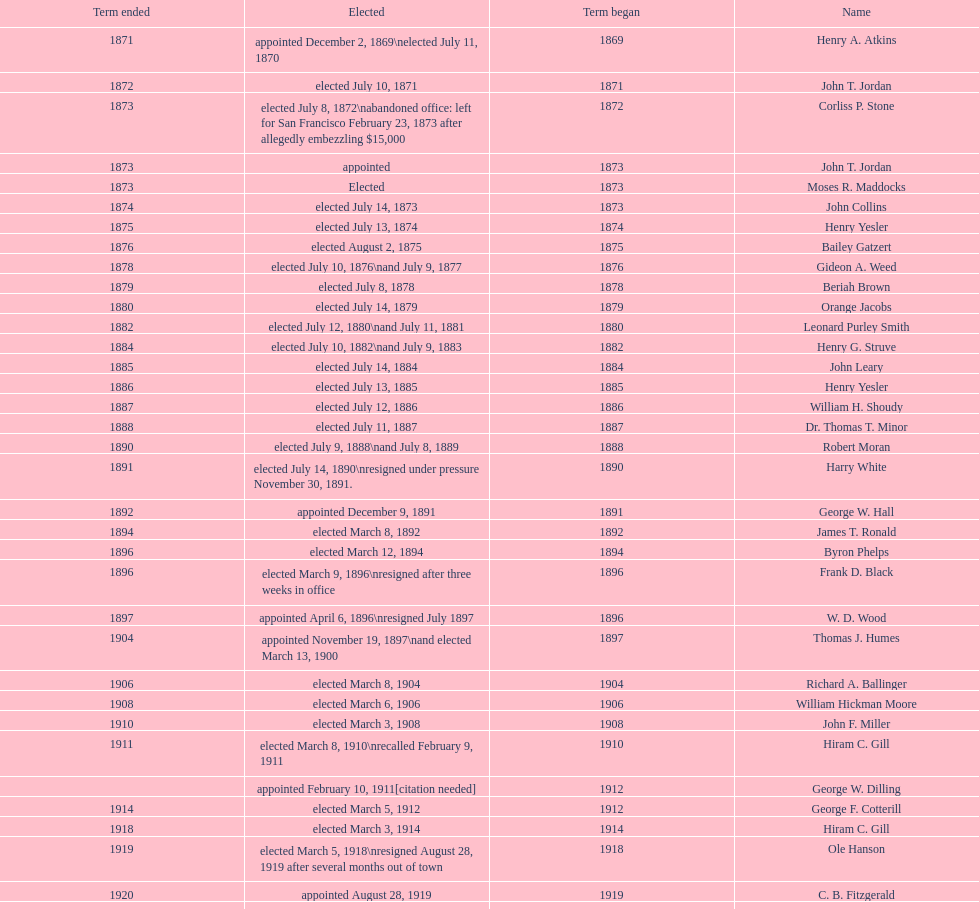Did charles royer hold office longer than paul schell? Yes. 